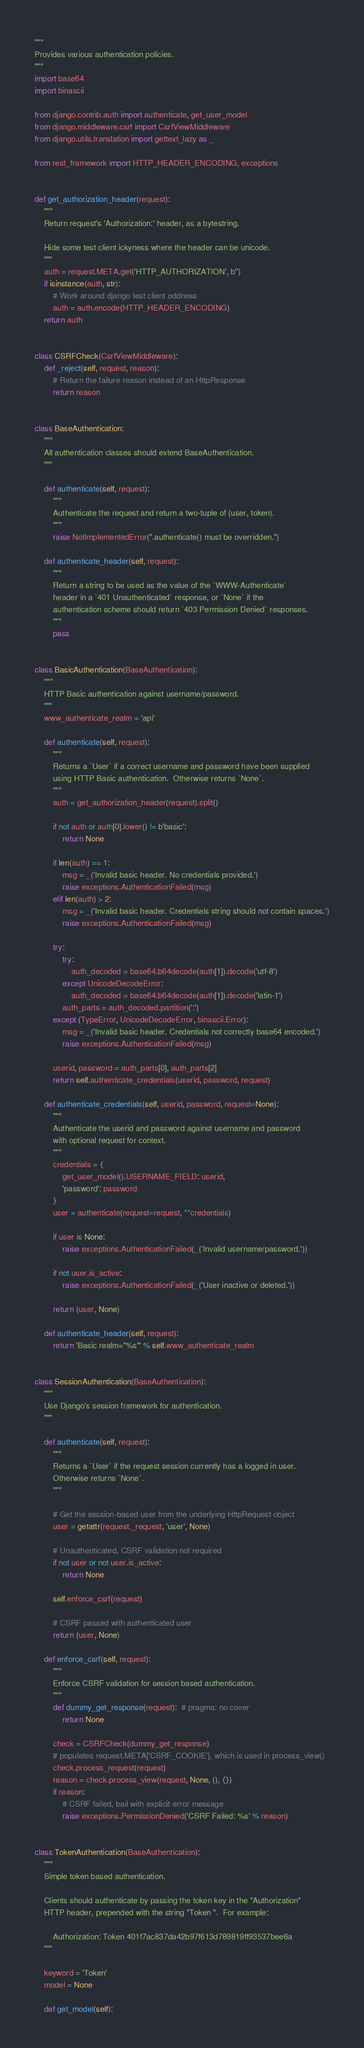Convert code to text. <code><loc_0><loc_0><loc_500><loc_500><_Python_>"""
Provides various authentication policies.
"""
import base64
import binascii

from django.contrib.auth import authenticate, get_user_model
from django.middleware.csrf import CsrfViewMiddleware
from django.utils.translation import gettext_lazy as _

from rest_framework import HTTP_HEADER_ENCODING, exceptions


def get_authorization_header(request):
    """
    Return request's 'Authorization:' header, as a bytestring.

    Hide some test client ickyness where the header can be unicode.
    """
    auth = request.META.get('HTTP_AUTHORIZATION', b'')
    if isinstance(auth, str):
        # Work around django test client oddness
        auth = auth.encode(HTTP_HEADER_ENCODING)
    return auth


class CSRFCheck(CsrfViewMiddleware):
    def _reject(self, request, reason):
        # Return the failure reason instead of an HttpResponse
        return reason


class BaseAuthentication:
    """
    All authentication classes should extend BaseAuthentication.
    """

    def authenticate(self, request):
        """
        Authenticate the request and return a two-tuple of (user, token).
        """
        raise NotImplementedError(".authenticate() must be overridden.")

    def authenticate_header(self, request):
        """
        Return a string to be used as the value of the `WWW-Authenticate`
        header in a `401 Unauthenticated` response, or `None` if the
        authentication scheme should return `403 Permission Denied` responses.
        """
        pass


class BasicAuthentication(BaseAuthentication):
    """
    HTTP Basic authentication against username/password.
    """
    www_authenticate_realm = 'api'

    def authenticate(self, request):
        """
        Returns a `User` if a correct username and password have been supplied
        using HTTP Basic authentication.  Otherwise returns `None`.
        """
        auth = get_authorization_header(request).split()

        if not auth or auth[0].lower() != b'basic':
            return None

        if len(auth) == 1:
            msg = _('Invalid basic header. No credentials provided.')
            raise exceptions.AuthenticationFailed(msg)
        elif len(auth) > 2:
            msg = _('Invalid basic header. Credentials string should not contain spaces.')
            raise exceptions.AuthenticationFailed(msg)

        try:
            try:
                auth_decoded = base64.b64decode(auth[1]).decode('utf-8')
            except UnicodeDecodeError:
                auth_decoded = base64.b64decode(auth[1]).decode('latin-1')
            auth_parts = auth_decoded.partition(':')
        except (TypeError, UnicodeDecodeError, binascii.Error):
            msg = _('Invalid basic header. Credentials not correctly base64 encoded.')
            raise exceptions.AuthenticationFailed(msg)

        userid, password = auth_parts[0], auth_parts[2]
        return self.authenticate_credentials(userid, password, request)

    def authenticate_credentials(self, userid, password, request=None):
        """
        Authenticate the userid and password against username and password
        with optional request for context.
        """
        credentials = {
            get_user_model().USERNAME_FIELD: userid,
            'password': password
        }
        user = authenticate(request=request, **credentials)

        if user is None:
            raise exceptions.AuthenticationFailed(_('Invalid username/password.'))

        if not user.is_active:
            raise exceptions.AuthenticationFailed(_('User inactive or deleted.'))

        return (user, None)

    def authenticate_header(self, request):
        return 'Basic realm="%s"' % self.www_authenticate_realm


class SessionAuthentication(BaseAuthentication):
    """
    Use Django's session framework for authentication.
    """

    def authenticate(self, request):
        """
        Returns a `User` if the request session currently has a logged in user.
        Otherwise returns `None`.
        """

        # Get the session-based user from the underlying HttpRequest object
        user = getattr(request._request, 'user', None)

        # Unauthenticated, CSRF validation not required
        if not user or not user.is_active:
            return None

        self.enforce_csrf(request)

        # CSRF passed with authenticated user
        return (user, None)

    def enforce_csrf(self, request):
        """
        Enforce CSRF validation for session based authentication.
        """
        def dummy_get_response(request):  # pragma: no cover
            return None

        check = CSRFCheck(dummy_get_response)
        # populates request.META['CSRF_COOKIE'], which is used in process_view()
        check.process_request(request)
        reason = check.process_view(request, None, (), {})
        if reason:
            # CSRF failed, bail with explicit error message
            raise exceptions.PermissionDenied('CSRF Failed: %s' % reason)


class TokenAuthentication(BaseAuthentication):
    """
    Simple token based authentication.

    Clients should authenticate by passing the token key in the "Authorization"
    HTTP header, prepended with the string "Token ".  For example:

        Authorization: Token 401f7ac837da42b97f613d789819ff93537bee6a
    """

    keyword = 'Token'
    model = None

    def get_model(self):</code> 